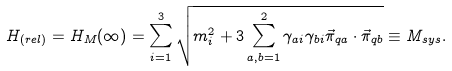Convert formula to latex. <formula><loc_0><loc_0><loc_500><loc_500>H _ { ( r e l ) } = H _ { M } ( \infty ) = \sum _ { i = 1 } ^ { 3 } \sqrt { m _ { i } ^ { 2 } + 3 \sum _ { a , b = 1 } ^ { 2 } \gamma _ { a i } \gamma _ { b i } { \vec { \pi } } _ { q a } \cdot { \vec { \pi } } _ { q b } } \equiv M _ { s y s } .</formula> 